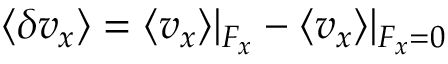<formula> <loc_0><loc_0><loc_500><loc_500>\langle \delta v _ { x } \rangle = \langle v _ { x } \rangle | _ { F _ { x } } - \langle v _ { x } \rangle | _ { F _ { x } = 0 }</formula> 